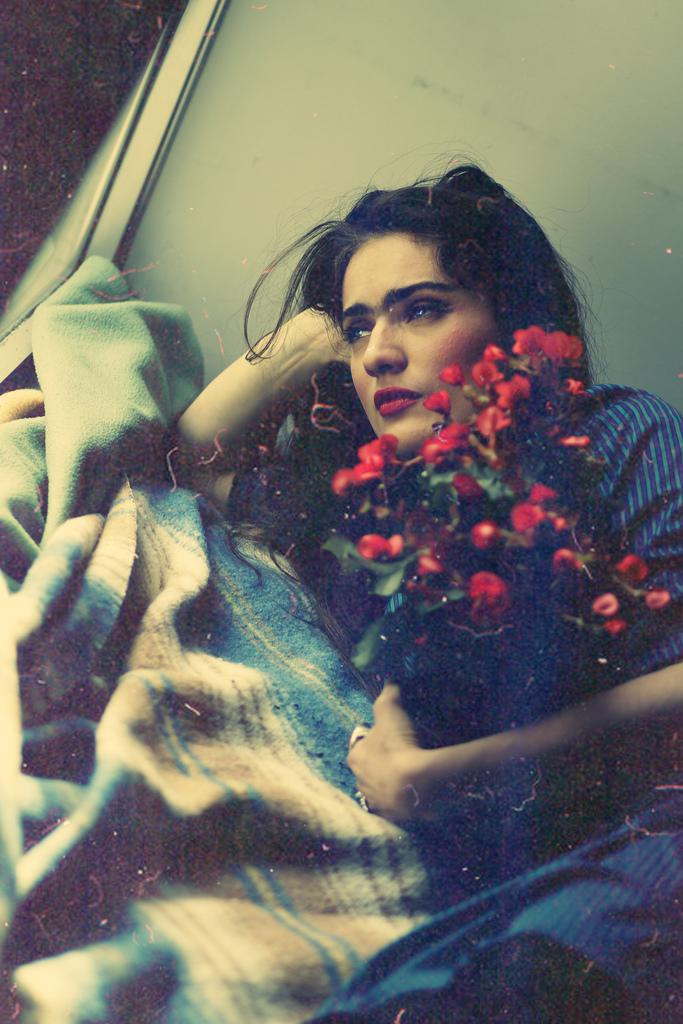Who is the main subject in the image? There is a woman in the image. What is the woman doing in the image? The woman is lying on the carpet. What is the woman holding in her hands? The woman is holding a bouquet in her hands. What type of crack is visible on the woman's toe in the image? There is no crack visible on the woman's toe in the image, nor is there any indication that the woman has a toe. 